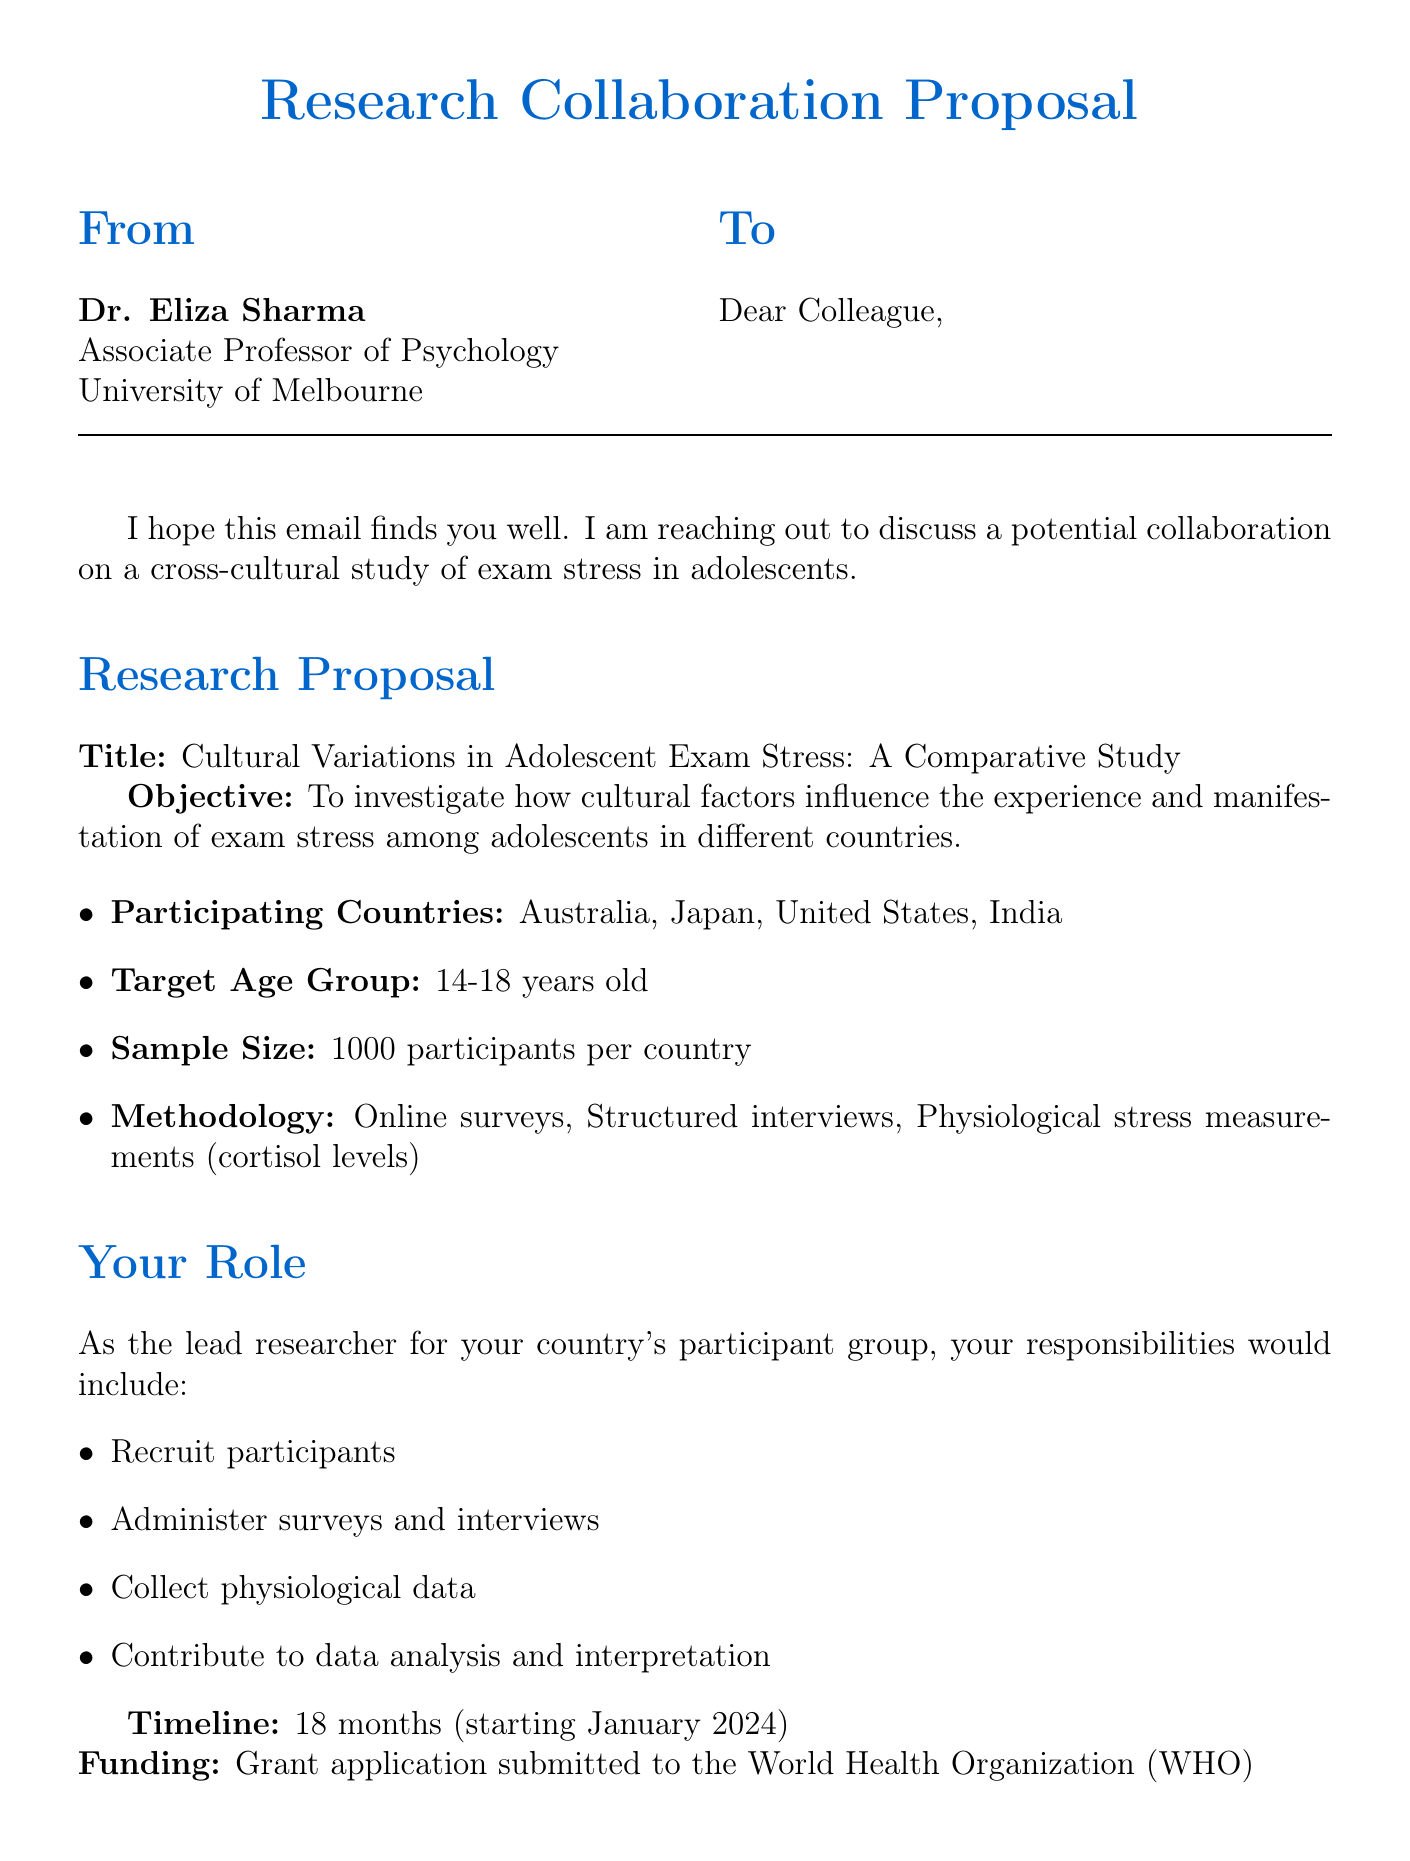what is the title of the research proposal? The title of the research proposal is mentioned in the document under the Research Proposal section.
Answer: Cultural Variations in Adolescent Exam Stress: A Comparative Study who is the sender of the email? The sender's name and title are provided at the top of the document.
Answer: Dr. Eliza Sharma how many participants will be involved in each country? The sample size per country is stated explicitly in the proposal.
Answer: 1000 participants what is the target age group for the study? The target age group is specified in the Research Proposal section.
Answer: 14-18 years old what is the duration of the study? The timeline for the study is detailed in the Collaboration Details section.
Answer: 18 months which countries are participating in the study? The participating countries are listed within the Research Proposal section.
Answer: Australia, Japan, United States, India what physiological data will be collected? The methodology mentions the type of physiological data to be measured.
Answer: cortisol levels what is the funding source mentioned in the proposal? The funding source for the research is noted in the Collaboration Details section.
Answer: World Health Organization (WHO) what is the suggested next step? The invitation for further discussion is found in the Closing Remarks section.
Answer: schedule a video call 